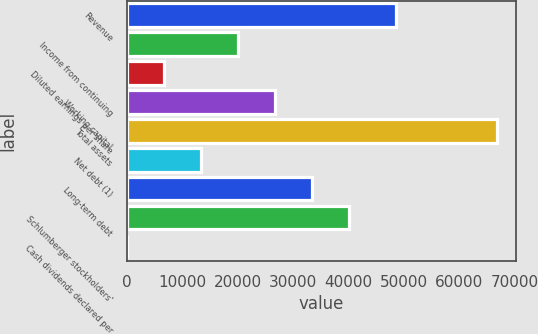Convert chart. <chart><loc_0><loc_0><loc_500><loc_500><bar_chart><fcel>Revenue<fcel>Income from continuing<fcel>Diluted earnings per share<fcel>Working capital<fcel>Total assets<fcel>Net debt (1)<fcel>Long-term debt<fcel>Schlumberger stockholders'<fcel>Cash dividends declared per<nl><fcel>48580<fcel>20072.3<fcel>6691.84<fcel>26762.6<fcel>66904<fcel>13382.1<fcel>33452.8<fcel>40143<fcel>1.6<nl></chart> 